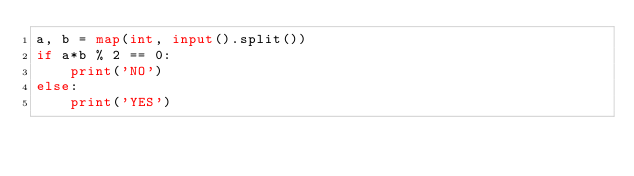Convert code to text. <code><loc_0><loc_0><loc_500><loc_500><_Python_>a, b = map(int, input().split())
if a*b % 2 == 0:
    print('NO')
else:
    print('YES')</code> 